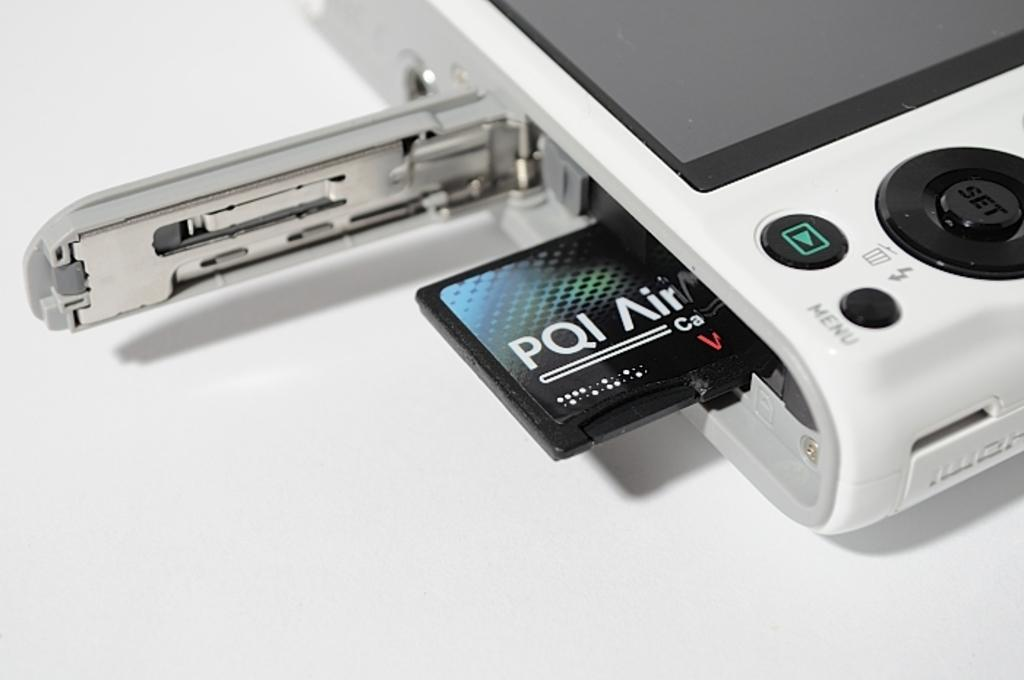What is the main object in the image? There is a camera in the image. What feature of the camera is visible in the image? There are buttons on the camera. What is the distance between the camera and the sea in the image? There is no sea present in the image, so it is not possible to determine the distance between the camera and the sea. 